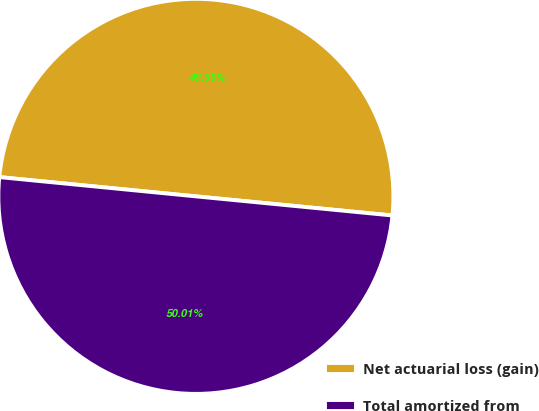Convert chart. <chart><loc_0><loc_0><loc_500><loc_500><pie_chart><fcel>Net actuarial loss (gain)<fcel>Total amortized from<nl><fcel>49.99%<fcel>50.01%<nl></chart> 